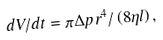<formula> <loc_0><loc_0><loc_500><loc_500>d V / d t = \pi \Delta p r ^ { 4 } / \left ( 8 \eta l \right ) ,</formula> 